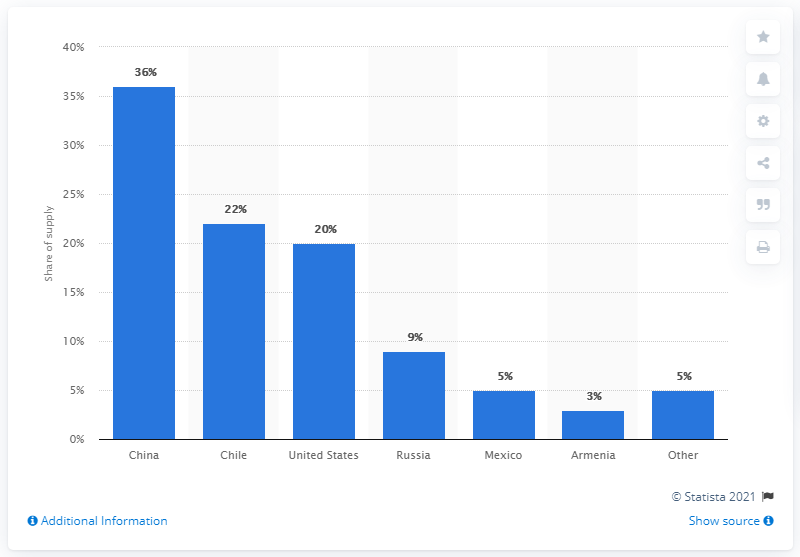Draw attention to some important aspects in this diagram. China is the largest molybdenum-producing country in the world. 